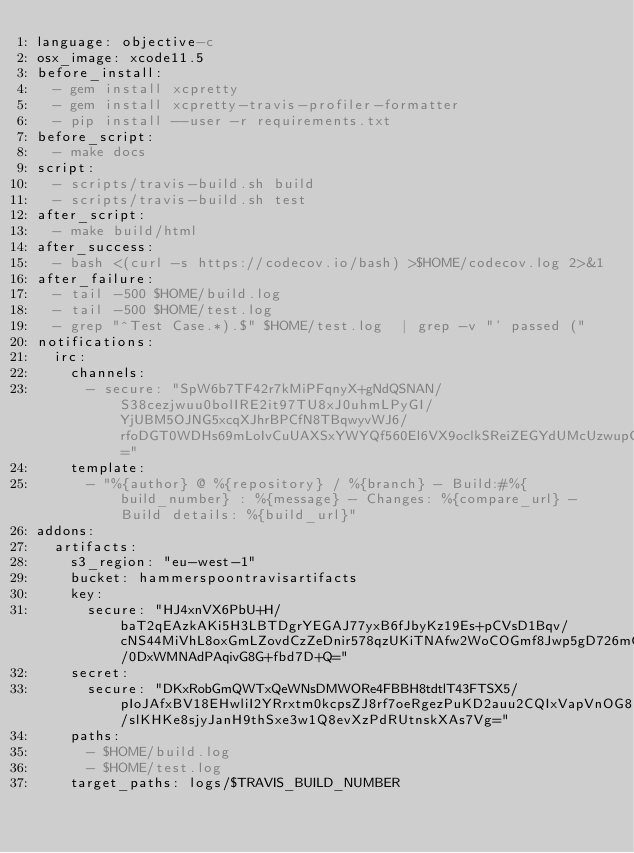<code> <loc_0><loc_0><loc_500><loc_500><_YAML_>language: objective-c
osx_image: xcode11.5
before_install:
  - gem install xcpretty
  - gem install xcpretty-travis-profiler-formatter
  - pip install --user -r requirements.txt
before_script:
  - make docs
script:
  - scripts/travis-build.sh build
  - scripts/travis-build.sh test
after_script:
  - make build/html
after_success:
  - bash <(curl -s https://codecov.io/bash) >$HOME/codecov.log 2>&1
after_failure:
  - tail -500 $HOME/build.log
  - tail -500 $HOME/test.log
  - grep "^Test Case.*).$" $HOME/test.log  | grep -v "' passed ("
notifications:
  irc:
    channels:
      - secure: "SpW6b7TF42r7kMiPFqnyX+gNdQSNAN/S38cezjwuu0bolIRE2it97TU8xJ0uhmLPyGI/YjUBM5OJNG5xcqXJhrBPCfN8TBqwyvWJ6/rfoDGT0WDHs69mLoIvCuUAXSxYWYQf560El6VX9oclkSReiZEGYdUMcUzwupCpMmcjUi4="
    template:
      - "%{author} @ %{repository} / %{branch} - Build:#%{build_number} : %{message} - Changes: %{compare_url} - Build details: %{build_url}"
addons:
  artifacts:
    s3_region: "eu-west-1"
    bucket: hammerspoontravisartifacts
    key:
      secure: "HJ4xnVX6PbU+H/baT2qEAzkAKi5H3LBTDgrYEGAJ77yxB6fJbyKz19Es+pCVsD1Bqv/cNS44MiVhL8oxGmLZovdCzZeDnir578qzUKiTNAfw2WoCOGmf8Jwp5gD726mCnpLtqefiHADK9VQ53p/0DxWMNAdPAqivG8G+fbd7D+Q="
    secret:
      secure: "DKxRobGmQWTxQeWNsDMWORe4FBBH8tdtlT43FTSX5/pIoJAfxBV18EHwliI2YRrxtm0kcpsZJ8rf7oeRgezPuKD2auu2CQIxVapVnOG8Lz6wEM8aHVq9OT4jbTusn1m/slKHKe8sjyJanH9thSxe3w1Q8evXzPdRUtnskXAs7Vg="
    paths:
      - $HOME/build.log
      - $HOME/test.log
    target_paths: logs/$TRAVIS_BUILD_NUMBER
</code> 